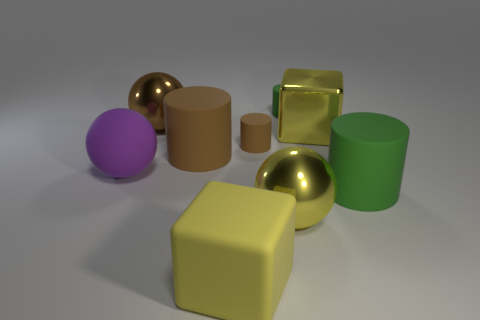Subtract all red blocks. How many brown cylinders are left? 2 Subtract all tiny green rubber cylinders. How many cylinders are left? 3 Subtract 2 cylinders. How many cylinders are left? 2 Add 1 big green rubber cubes. How many objects exist? 10 Subtract all gray cylinders. Subtract all brown cubes. How many cylinders are left? 4 Subtract all cylinders. How many objects are left? 5 Add 5 brown rubber cylinders. How many brown rubber cylinders are left? 7 Add 1 large matte objects. How many large matte objects exist? 5 Subtract 0 blue spheres. How many objects are left? 9 Subtract all green things. Subtract all large red cubes. How many objects are left? 7 